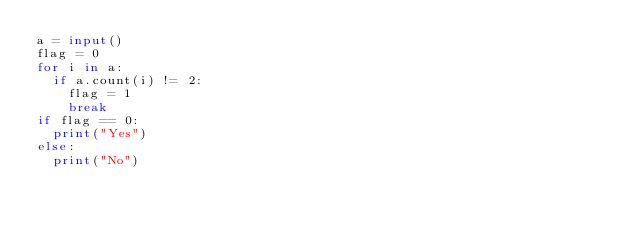Convert code to text. <code><loc_0><loc_0><loc_500><loc_500><_Python_>a = input()
flag = 0
for i in a:
  if a.count(i) != 2:
    flag = 1
    break
if flag == 0:
  print("Yes")
else:
  print("No")</code> 